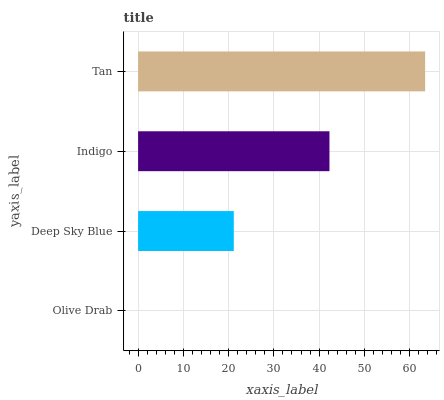Is Olive Drab the minimum?
Answer yes or no. Yes. Is Tan the maximum?
Answer yes or no. Yes. Is Deep Sky Blue the minimum?
Answer yes or no. No. Is Deep Sky Blue the maximum?
Answer yes or no. No. Is Deep Sky Blue greater than Olive Drab?
Answer yes or no. Yes. Is Olive Drab less than Deep Sky Blue?
Answer yes or no. Yes. Is Olive Drab greater than Deep Sky Blue?
Answer yes or no. No. Is Deep Sky Blue less than Olive Drab?
Answer yes or no. No. Is Indigo the high median?
Answer yes or no. Yes. Is Deep Sky Blue the low median?
Answer yes or no. Yes. Is Tan the high median?
Answer yes or no. No. Is Tan the low median?
Answer yes or no. No. 